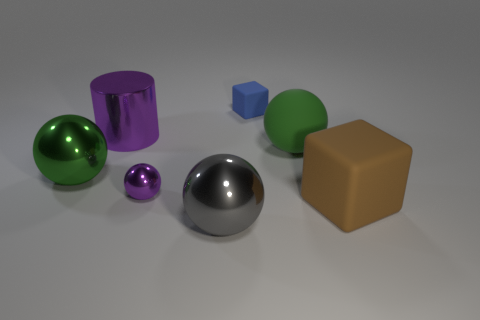There is another sphere that is the same color as the rubber ball; what size is it?
Give a very brief answer. Large. What number of objects are in front of the large brown block and behind the metal cylinder?
Give a very brief answer. 0. What color is the matte cube to the left of the sphere that is behind the metal sphere left of the tiny purple shiny thing?
Offer a terse response. Blue. How many other objects are there of the same shape as the large purple shiny object?
Give a very brief answer. 0. There is a metal thing that is behind the green shiny object; are there any big matte spheres that are on the left side of it?
Provide a succinct answer. No. How many rubber things are either large yellow spheres or tiny blue cubes?
Provide a succinct answer. 1. The thing that is behind the big brown block and to the right of the blue object is made of what material?
Ensure brevity in your answer.  Rubber. There is a large metallic ball that is in front of the large cube in front of the tiny blue block; is there a large rubber sphere that is right of it?
Ensure brevity in your answer.  Yes. Is there anything else that has the same material as the purple cylinder?
Offer a very short reply. Yes. What is the shape of the large green thing that is the same material as the big purple cylinder?
Keep it short and to the point. Sphere. 